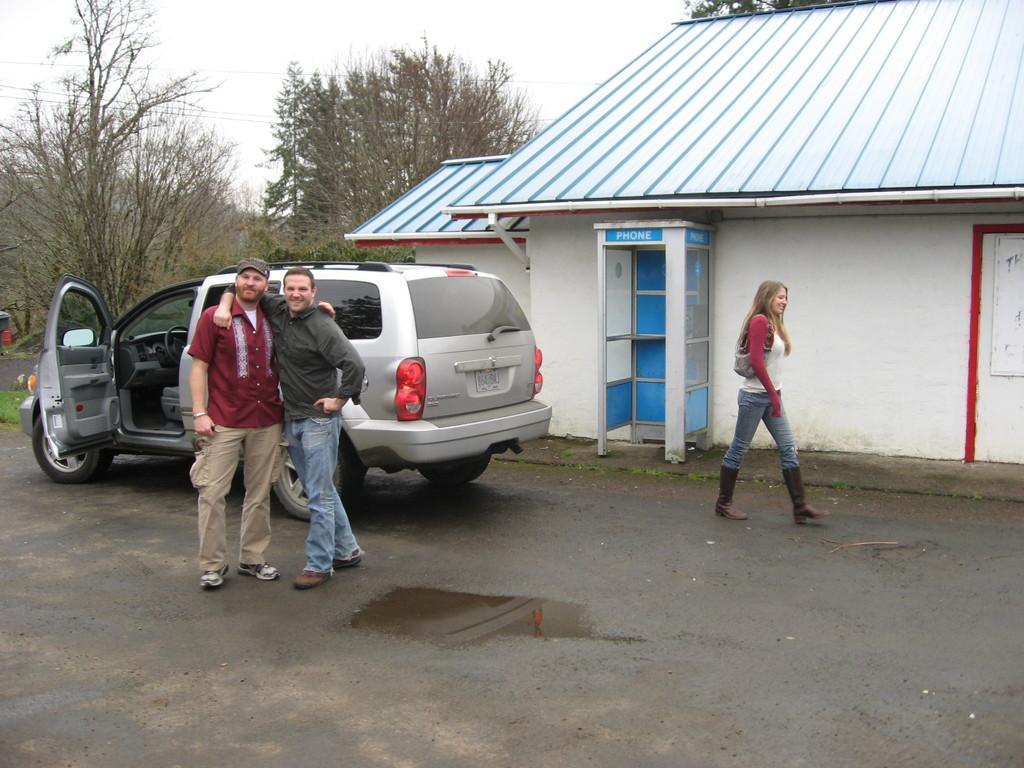How many people are present in the image? There are three people in the image. What vehicle can be seen in the image? There is a car in the image. What type of building is visible in the image? There is a house in the image. What natural elements are present around the house? There are trees around the house in the image. What type of caption is written on the car in the image? There is no caption written on the car in the image. How many roses can be seen growing near the house in the image? There are no roses present in the image; only trees are visible around the house. 